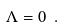Convert formula to latex. <formula><loc_0><loc_0><loc_500><loc_500>\Lambda = 0 \ .</formula> 